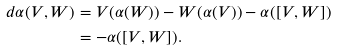<formula> <loc_0><loc_0><loc_500><loc_500>d \alpha ( V , W ) & = V ( \alpha ( W ) ) - W ( \alpha ( V ) ) - \alpha ( [ V , W ] ) \\ & = - \alpha ( [ V , W ] ) .</formula> 